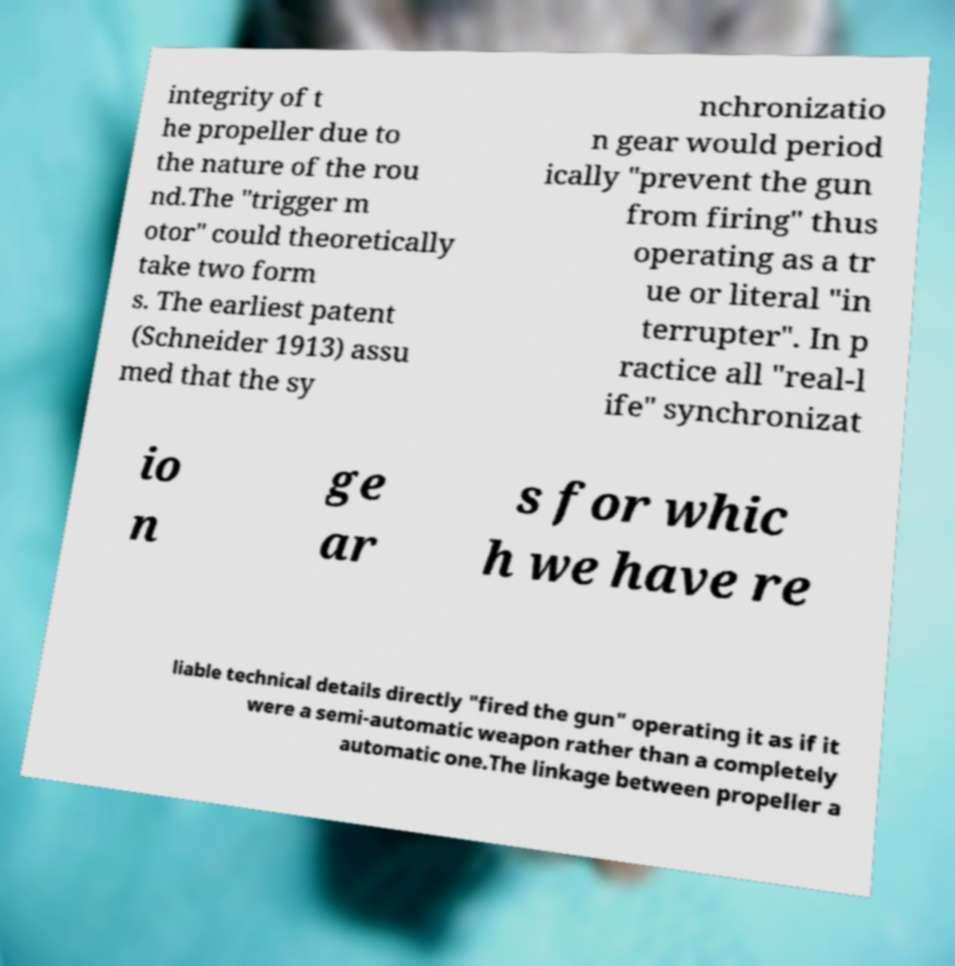I need the written content from this picture converted into text. Can you do that? integrity of t he propeller due to the nature of the rou nd.The "trigger m otor" could theoretically take two form s. The earliest patent (Schneider 1913) assu med that the sy nchronizatio n gear would period ically "prevent the gun from firing" thus operating as a tr ue or literal "in terrupter". In p ractice all "real-l ife" synchronizat io n ge ar s for whic h we have re liable technical details directly "fired the gun" operating it as if it were a semi-automatic weapon rather than a completely automatic one.The linkage between propeller a 